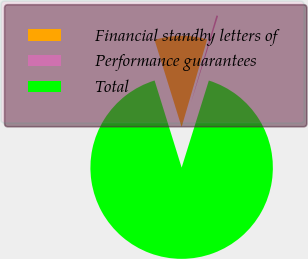Convert chart to OTSL. <chart><loc_0><loc_0><loc_500><loc_500><pie_chart><fcel>Financial standby letters of<fcel>Performance guarantees<fcel>Total<nl><fcel>9.31%<fcel>0.3%<fcel>90.39%<nl></chart> 